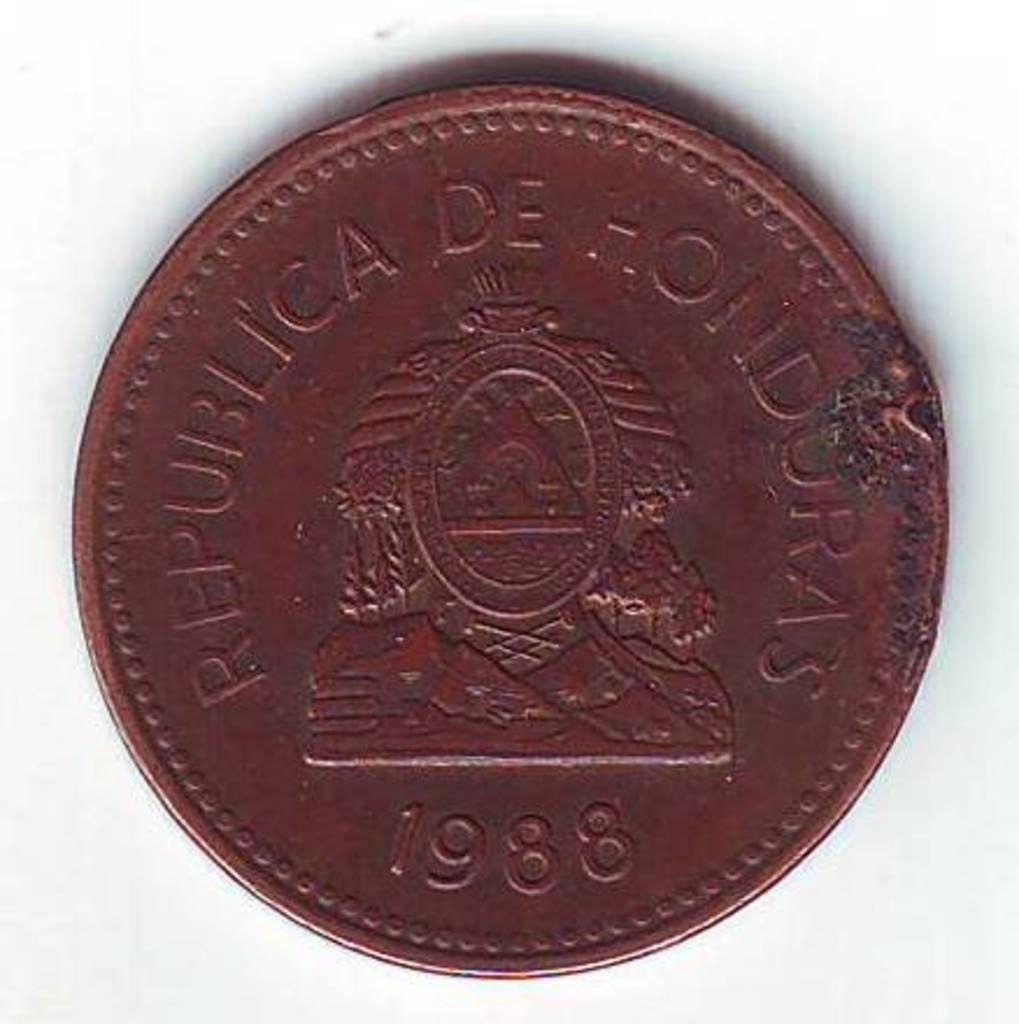<image>
Relay a brief, clear account of the picture shown. Republica De Honduras type bronze coin from 1988. 